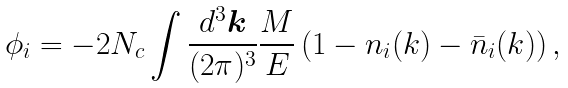Convert formula to latex. <formula><loc_0><loc_0><loc_500><loc_500>\phi _ { i } = - 2 N _ { c } \int \frac { d ^ { 3 } \boldsymbol k } { ( 2 \pi ) ^ { 3 } } \frac { M } { E } \left ( 1 - n _ { i } ( k ) - \bar { n } _ { i } ( k ) \right ) ,</formula> 